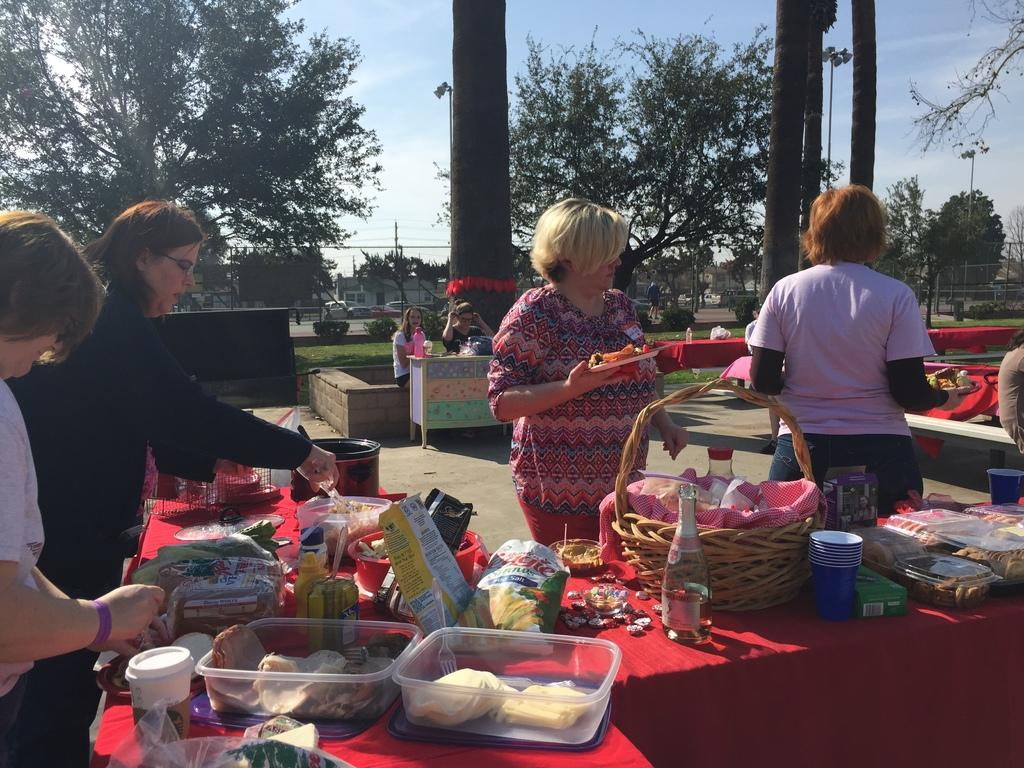Who is present in the image? There are women in the image. What is the color of the table in the image? There is a red color table in the image. What is on the table in the image? There is food on the table and bottles placed on the table. What can be seen in the background of the image? There are trees and the sky visible in the background of the image. What type of brake is visible on the table in the image? There is no brake present in the image; it is a table with food and bottles. Who is the representative of the group in the image? The image does not depict a group or any representative; it only shows women. 